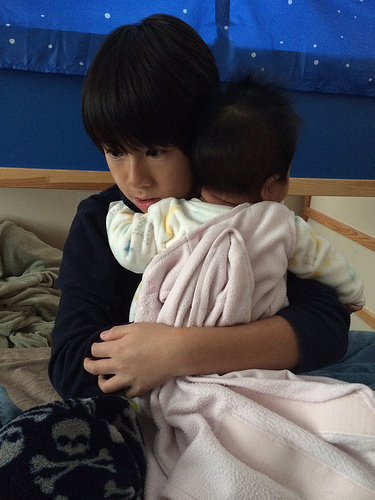<image>
Is the women on the kid? Yes. Looking at the image, I can see the women is positioned on top of the kid, with the kid providing support. Is the jacket in front of the baby? Yes. The jacket is positioned in front of the baby, appearing closer to the camera viewpoint. Where is the baby in relation to the mother? Is it to the right of the mother? No. The baby is not to the right of the mother. The horizontal positioning shows a different relationship. 